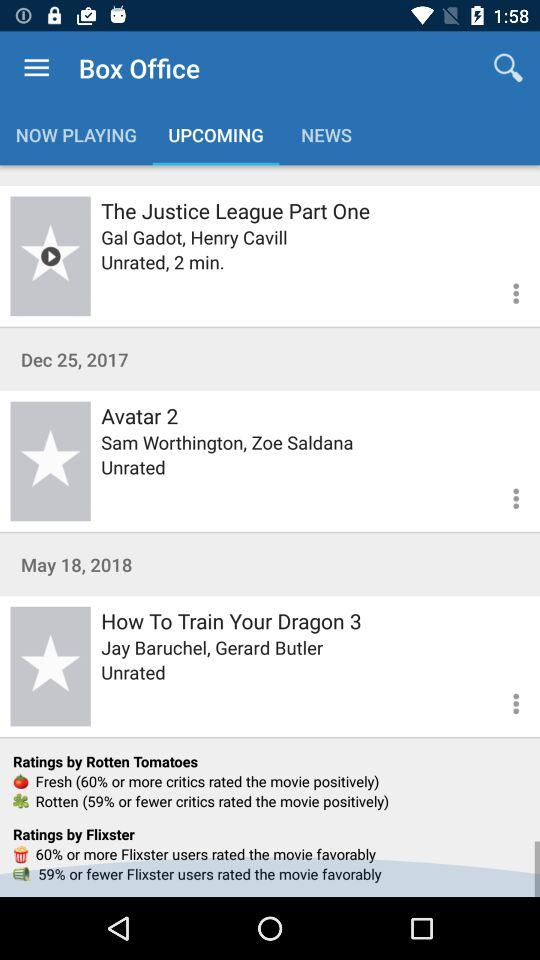How many movies have a release date after Dec 25, 2017?
Answer the question using a single word or phrase. 2 